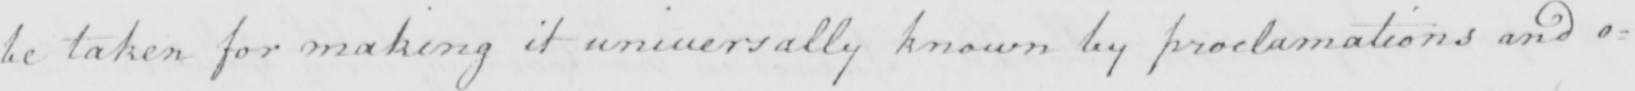What is written in this line of handwriting? be taken for making it universally known by proclamations and o= 